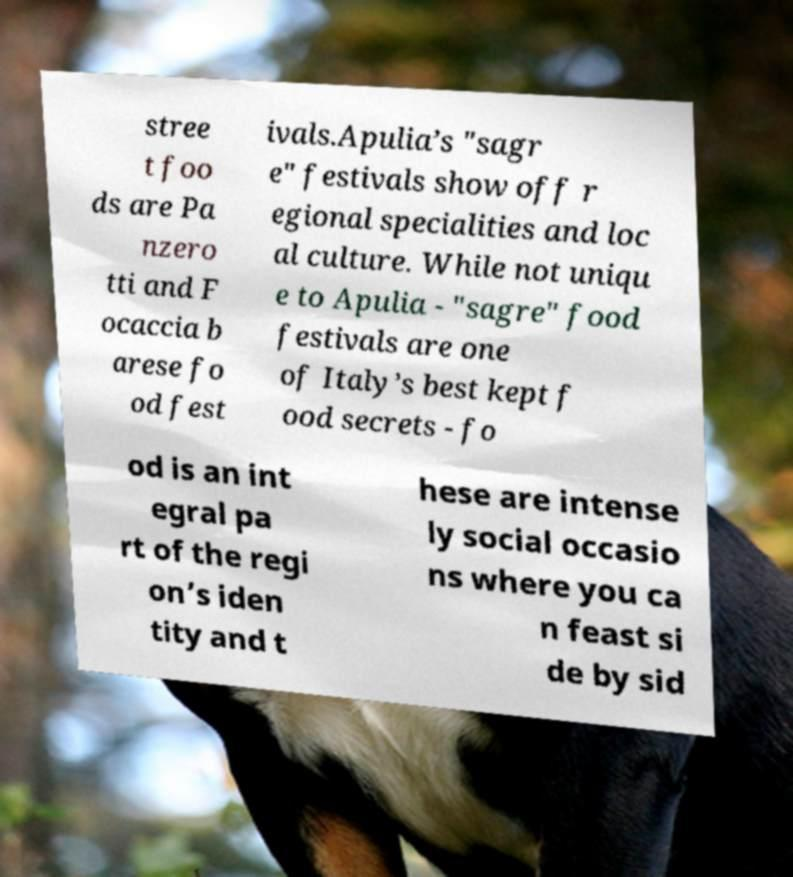There's text embedded in this image that I need extracted. Can you transcribe it verbatim? stree t foo ds are Pa nzero tti and F ocaccia b arese fo od fest ivals.Apulia’s "sagr e" festivals show off r egional specialities and loc al culture. While not uniqu e to Apulia - "sagre" food festivals are one of Italy’s best kept f ood secrets - fo od is an int egral pa rt of the regi on’s iden tity and t hese are intense ly social occasio ns where you ca n feast si de by sid 